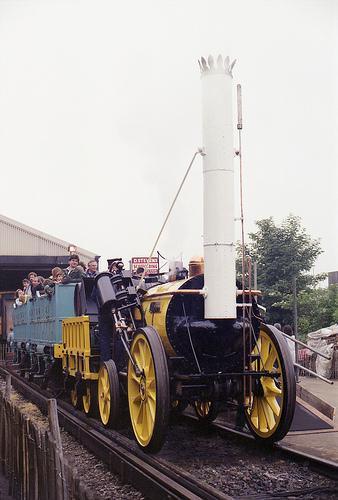How many trains are there?
Give a very brief answer. 1. 